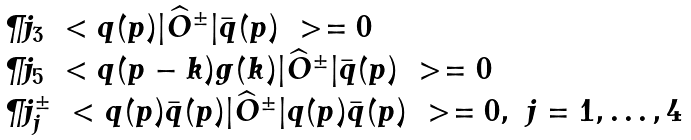<formula> <loc_0><loc_0><loc_500><loc_500>\begin{array} { l } \P j _ { 3 } \ < q ( p ) | \widehat { O } ^ { \pm } | \bar { q } ( p ) \ > = 0 \\ \P j _ { 5 } \ < q ( p - k ) g ( k ) | \widehat { O } ^ { \pm } | \bar { q } ( p ) \ > = 0 \\ \P j ^ { \pm } _ { j } \ < q ( p ) \bar { q } ( p ) | \widehat { O } ^ { \pm } | q ( p ) \bar { q } ( p ) \ > = 0 , \ j = 1 , \dots , 4 \end{array}</formula> 